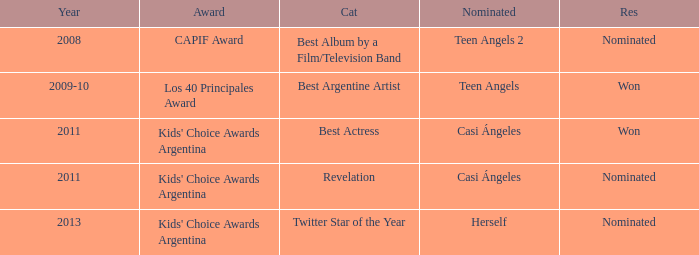What year was Teen Angels 2 nominated? 2008.0. 